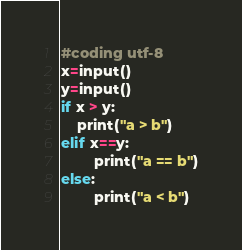<code> <loc_0><loc_0><loc_500><loc_500><_Python_>#coding utf-8
x=input()
y=input()
if x > y:
    print("a > b")
elif x==y:
        print("a == b")
else:
        print("a < b")</code> 